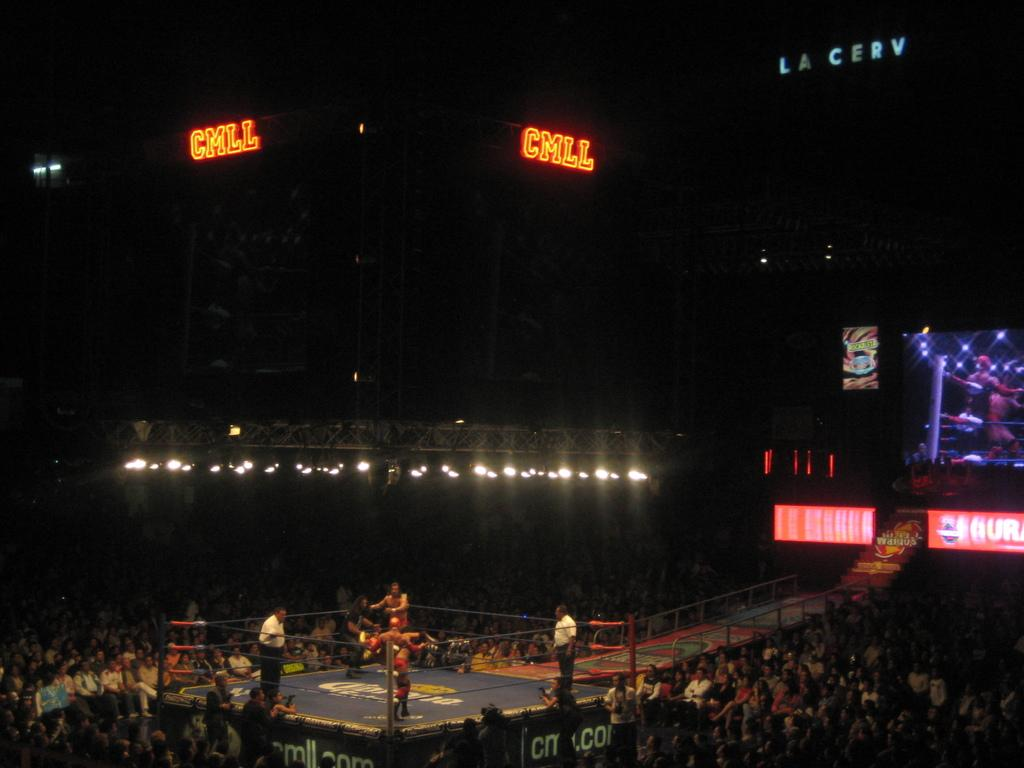<image>
Relay a brief, clear account of the picture shown. A wrestling ring with the word Chill on the screen above it. 